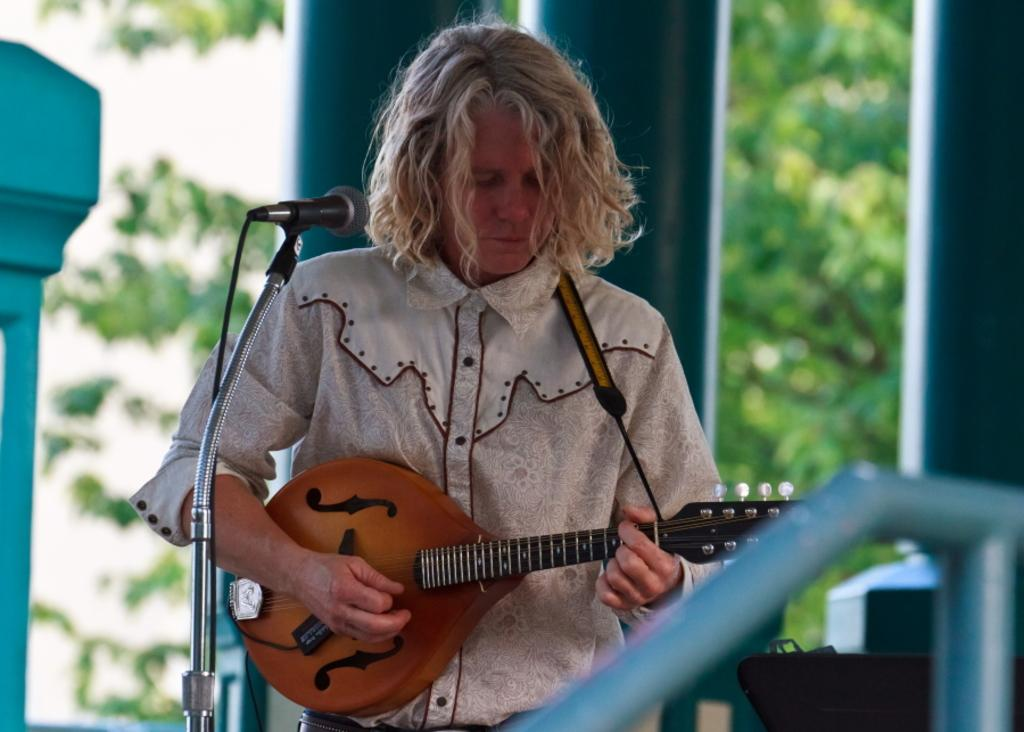What is the main subject of the image? The main subject of the image is a woman. What is the woman doing in the image? The woman is standing and playing a guitar. Is there any equipment near the woman? Yes, the woman is near a microphone. What can be seen in the background of the image? There are trees and a building in the background of the image. What type of bag is the woman carrying in the image? There is no bag visible in the image. Can you tell me how many stalks of celery are in the woman's hand? There is no celery present in the image. 